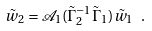Convert formula to latex. <formula><loc_0><loc_0><loc_500><loc_500>\tilde { w } _ { 2 } = \mathcal { A } _ { 1 } ( \tilde { \Gamma } _ { 2 } ^ { - 1 } \tilde { \Gamma } _ { 1 } ) \tilde { w } _ { 1 } \ .</formula> 